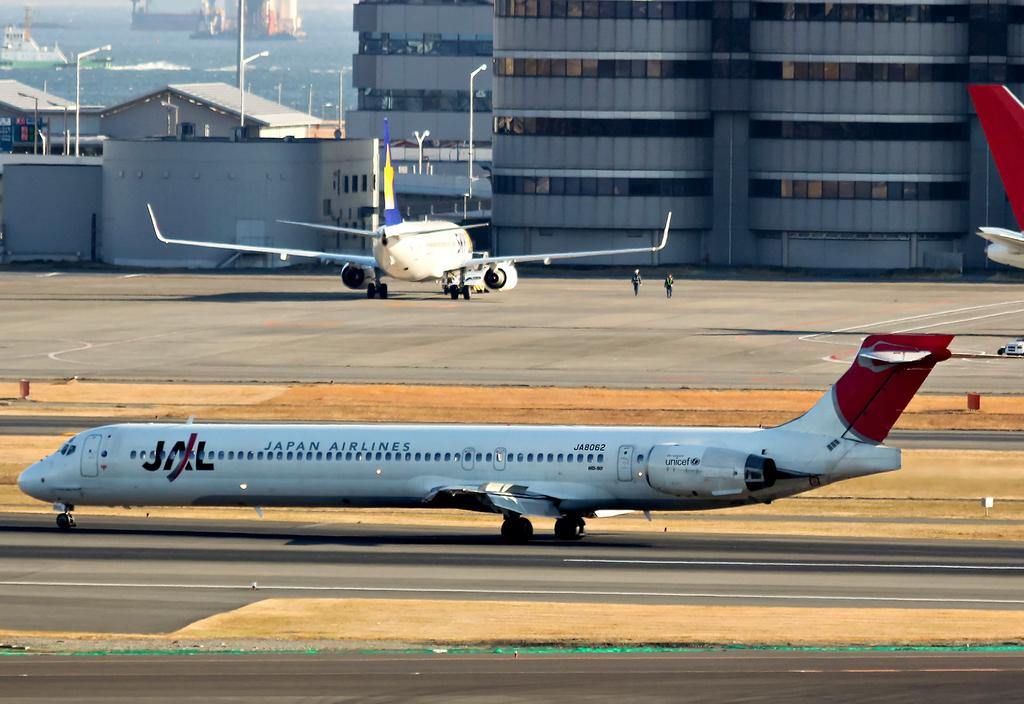How many airplanes can be seen in the image? There are two airplanes in the image. What can be seen in the background of the image? There are buildings in the background of the image. Which part of one airplane is visible in the image? The back part of one airplane is visible on the right side of the image. What type of soda is being served on the airplane in the image? There is no soda visible in the image, as it only features two airplanes and buildings in the background. 